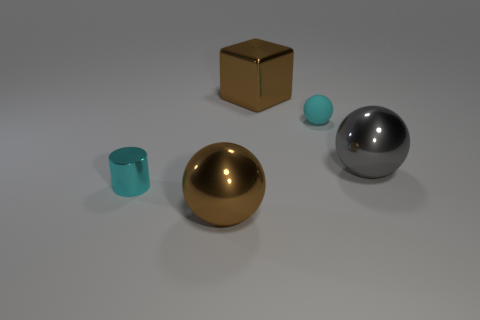Are there any other things that are the same material as the small ball?
Your answer should be compact. No. Are there any gray metallic objects that have the same size as the cyan matte sphere?
Give a very brief answer. No. Is the material of the cyan ball the same as the cyan cylinder?
Keep it short and to the point. No. What number of objects are purple shiny cylinders or gray balls?
Your answer should be compact. 1. The cyan ball has what size?
Your response must be concise. Small. Are there fewer big blue objects than shiny cylinders?
Ensure brevity in your answer.  Yes. What number of balls are the same color as the metal block?
Ensure brevity in your answer.  1. Do the big ball to the left of the cyan ball and the large block have the same color?
Give a very brief answer. Yes. There is a tiny thing that is to the left of the large metal block; what is its shape?
Your response must be concise. Cylinder. There is a big brown thing in front of the cyan sphere; is there a shiny cylinder that is left of it?
Provide a succinct answer. Yes. 